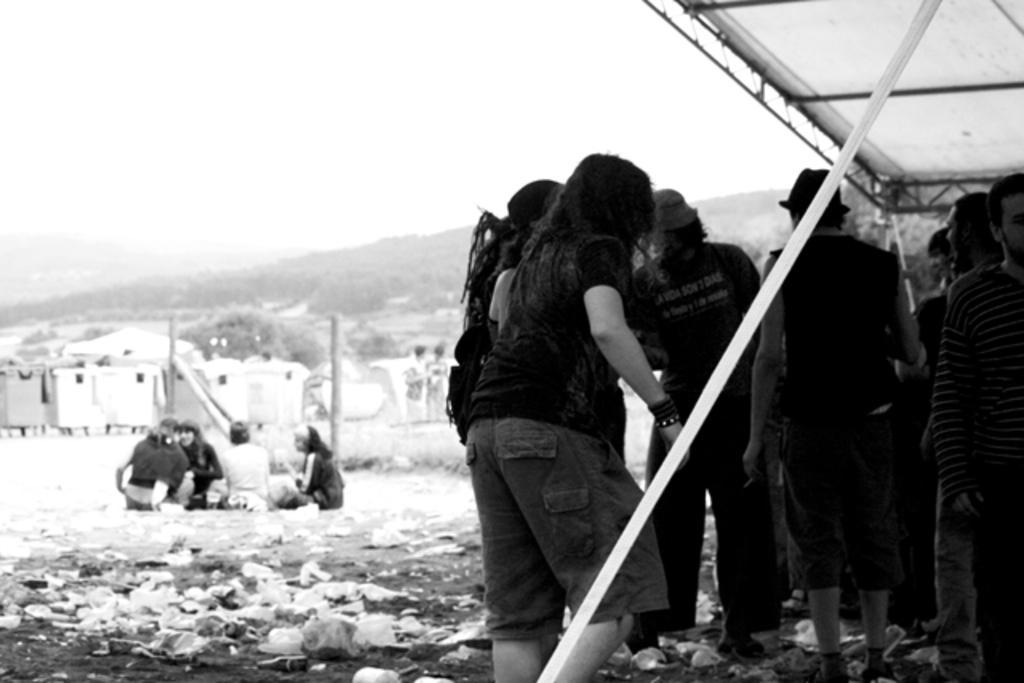Please provide a concise description of this image. In this image there is the sky, there are mountains truncated towards the left of the image, there are trees, there are objects on the ground, there are persons sitting on the ground, there are poles, there are group of persons, there is a person truncated towards the right of the image, there are persons truncated towards the bottom of the image, there is an object truncated towards the top of the image, there is an object truncated towards the right of the image, there is an object truncated towards the bottom of the image. 